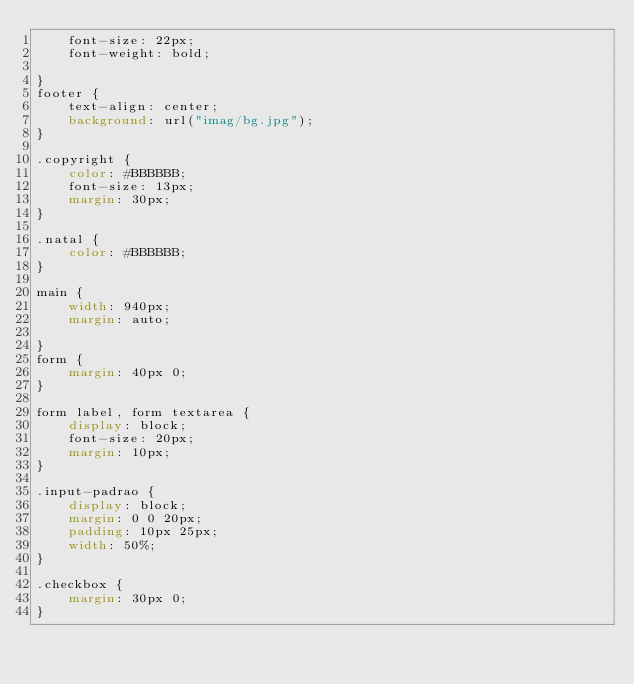<code> <loc_0><loc_0><loc_500><loc_500><_CSS_>	font-size: 22px;
	font-weight: bold;
	
}
footer {
	text-align: center;
	background: url("imag/bg.jpg");
}

.copyright {
    color: #BBBBBB;
    font-size: 13px;
    margin: 30px;
}

.natal {
	color: #BBBBBB;
}

main {
	width: 940px;
	margin: auto;

}
form {
	margin: 40px 0;
}

form label, form textarea {
	display: block;
	font-size: 20px;
	margin: 10px;
}

.input-padrao {
	display: block;
	margin: 0 0 20px;
	padding: 10px 25px;
	width: 50%;
}

.checkbox {
	margin: 30px 0;
}

</code> 